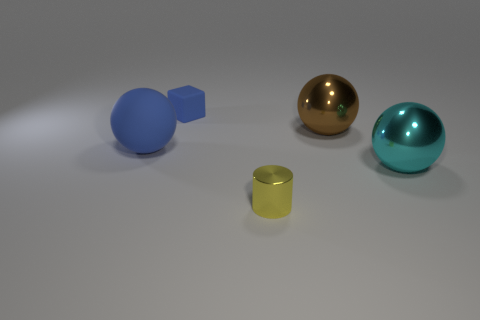Add 2 big yellow shiny objects. How many objects exist? 7 Subtract all spheres. How many objects are left? 2 Add 5 blue cubes. How many blue cubes are left? 6 Add 4 big yellow balls. How many big yellow balls exist? 4 Subtract 0 red cylinders. How many objects are left? 5 Subtract all big brown metal balls. Subtract all yellow metal cylinders. How many objects are left? 3 